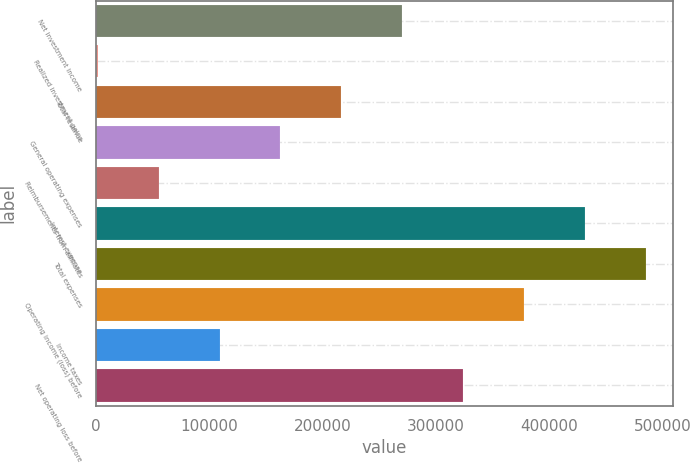Convert chart to OTSL. <chart><loc_0><loc_0><loc_500><loc_500><bar_chart><fcel>Net investment income<fcel>Realized investment gains<fcel>Total revenue<fcel>General operating expenses<fcel>Reimbursements from affiliates<fcel>Interest expense<fcel>Total expenses<fcel>Operating income (loss) before<fcel>Income taxes<fcel>Net operating loss before<nl><fcel>270370<fcel>1646<fcel>216625<fcel>162880<fcel>55390.8<fcel>431604<fcel>485349<fcel>377860<fcel>109136<fcel>324115<nl></chart> 